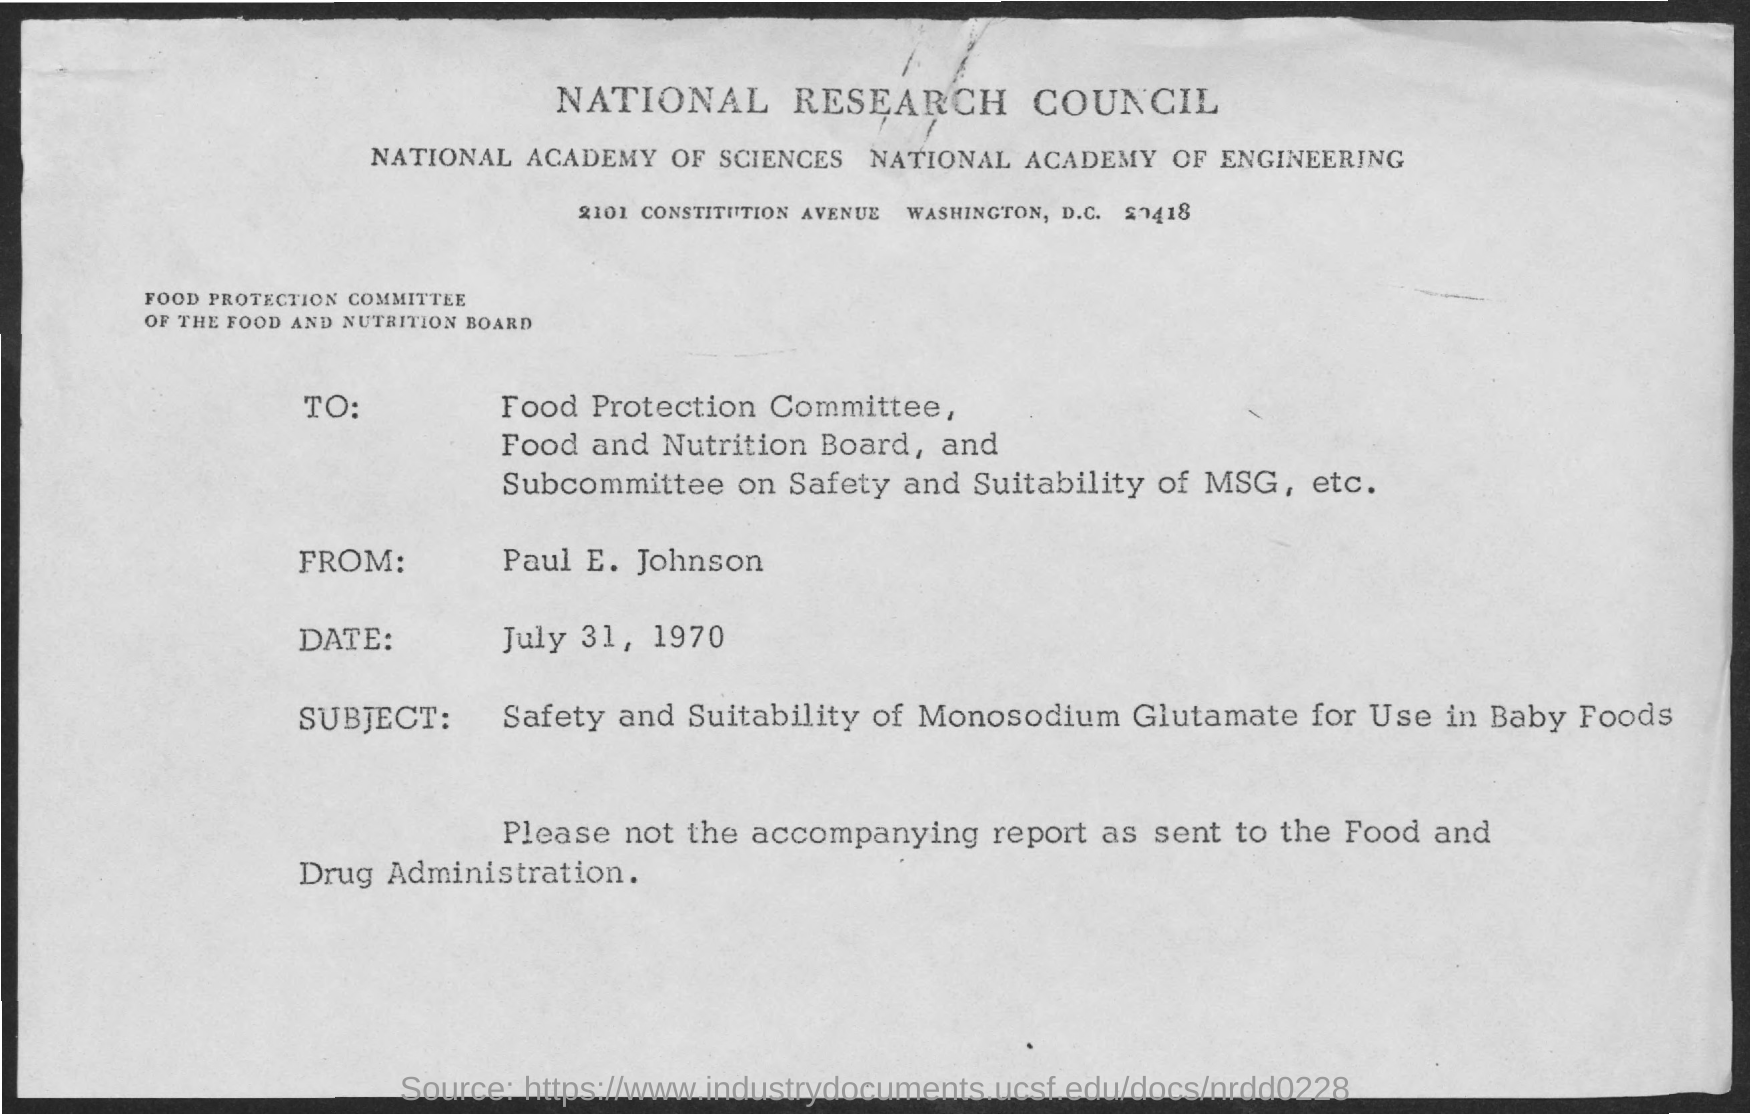What is the first title in the document?
Provide a short and direct response. National Research Council. What is the date mentioned in the document?
Your response must be concise. July 31, 1970. 